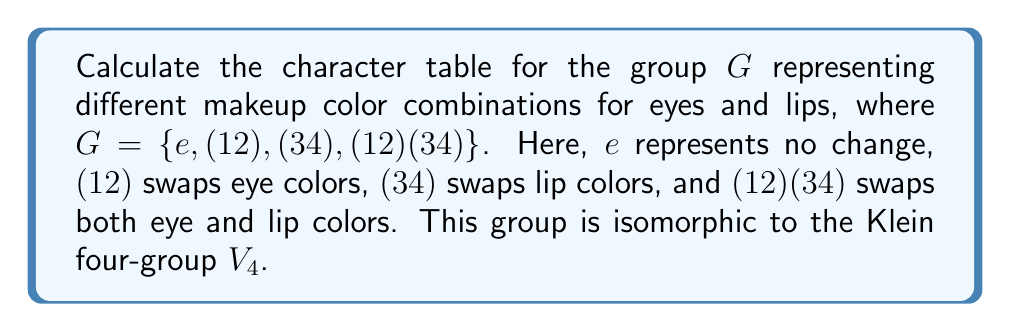Help me with this question. Let's approach this step-by-step:

1) First, we need to identify the conjugacy classes of $G$. Since $G$ is abelian, each element forms its own conjugacy class:
   $\{e\}$, $\{(12)\}$, $\{(34)\}$, $\{(12)(34)\}$

2) The number of irreducible representations is equal to the number of conjugacy classes, so we'll have 4 irreducible representations.

3) For an abelian group, all irreducible representations are 1-dimensional, so our character table will be 4x4.

4) The first row of the character table always corresponds to the trivial representation, where all elements map to 1.

5) For the remaining representations, we can use the fact that characters are homomorphisms from $G$ to $\mathbb{C}^*$. This means:
   - $\chi((12)(34)) = \chi((12)) \cdot \chi((34))$
   - $\chi(g)^2 = 1$ for all $g \in G$ (since all elements have order 2)

6) Using these facts, we can deduce the remaining rows:
   - One representation where $\chi((12)) = -1$ and $\chi((34)) = 1$
   - One representation where $\chi((12)) = 1$ and $\chi((34)) = -1$
   - One representation where $\chi((12)) = -1$ and $\chi((34)) = -1$

7) We can now construct the character table:

   $$
   \begin{array}{c|cccc}
   G & e & (12) & (34) & (12)(34) \\
   \hline
   \chi_1 & 1 & 1 & 1 & 1 \\
   \chi_2 & 1 & -1 & 1 & -1 \\
   \chi_3 & 1 & 1 & -1 & -1 \\
   \chi_4 & 1 & -1 & -1 & 1
   \end{array}
   $$

This character table represents how the makeup color combinations transform under different swapping operations.
Answer: $$
\begin{array}{c|cccc}
G & e & (12) & (34) & (12)(34) \\
\hline
\chi_1 & 1 & 1 & 1 & 1 \\
\chi_2 & 1 & -1 & 1 & -1 \\
\chi_3 & 1 & 1 & -1 & -1 \\
\chi_4 & 1 & -1 & -1 & 1
\end{array}
$$ 